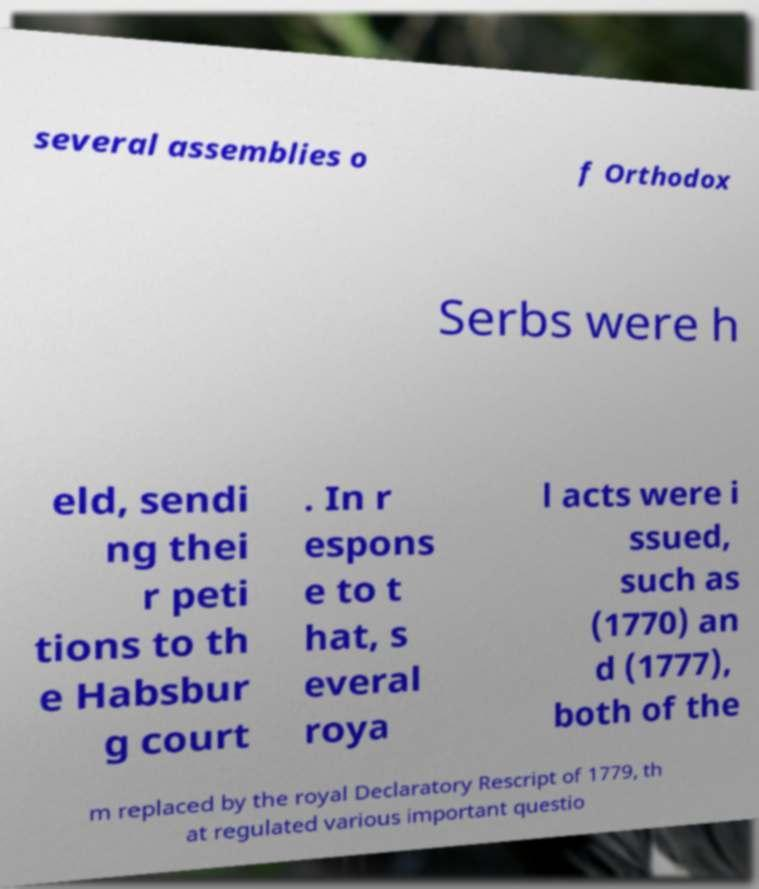There's text embedded in this image that I need extracted. Can you transcribe it verbatim? several assemblies o f Orthodox Serbs were h eld, sendi ng thei r peti tions to th e Habsbur g court . In r espons e to t hat, s everal roya l acts were i ssued, such as (1770) an d (1777), both of the m replaced by the royal Declaratory Rescript of 1779, th at regulated various important questio 